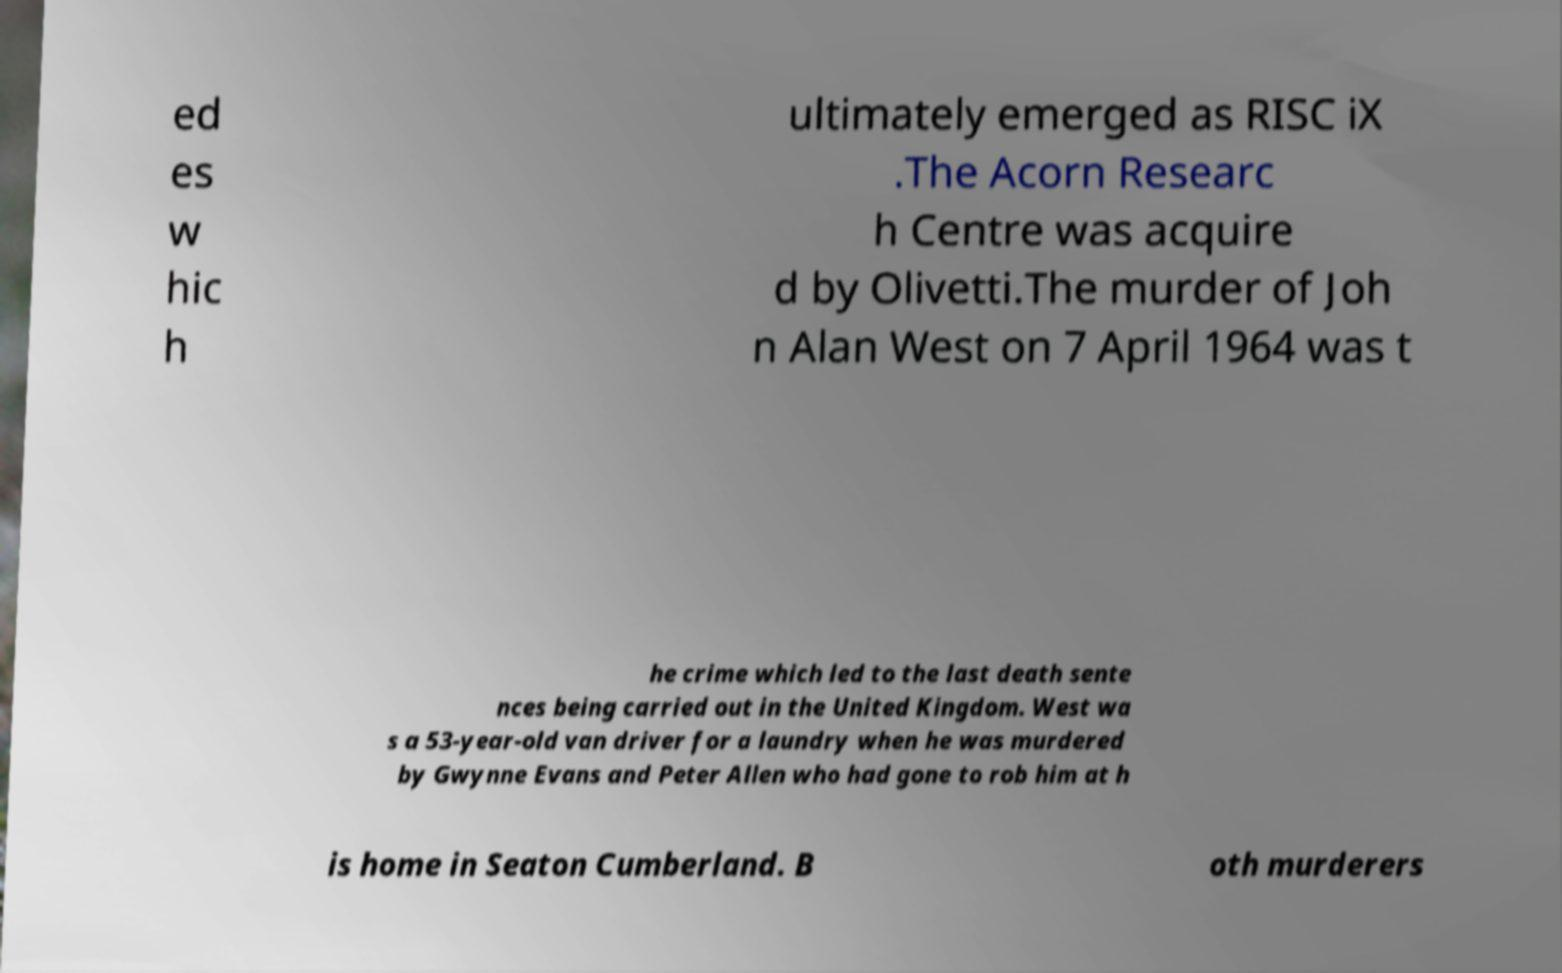There's text embedded in this image that I need extracted. Can you transcribe it verbatim? ed es w hic h ultimately emerged as RISC iX .The Acorn Researc h Centre was acquire d by Olivetti.The murder of Joh n Alan West on 7 April 1964 was t he crime which led to the last death sente nces being carried out in the United Kingdom. West wa s a 53-year-old van driver for a laundry when he was murdered by Gwynne Evans and Peter Allen who had gone to rob him at h is home in Seaton Cumberland. B oth murderers 